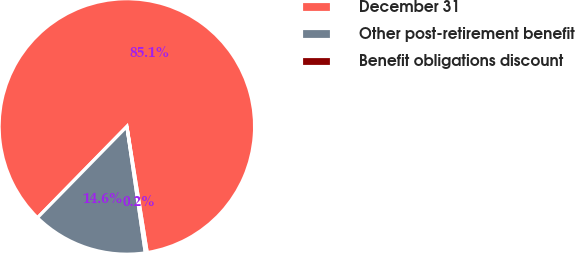Convert chart to OTSL. <chart><loc_0><loc_0><loc_500><loc_500><pie_chart><fcel>December 31<fcel>Other post-retirement benefit<fcel>Benefit obligations discount<nl><fcel>85.12%<fcel>14.64%<fcel>0.24%<nl></chart> 